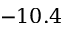Convert formula to latex. <formula><loc_0><loc_0><loc_500><loc_500>- 1 0 . 4</formula> 